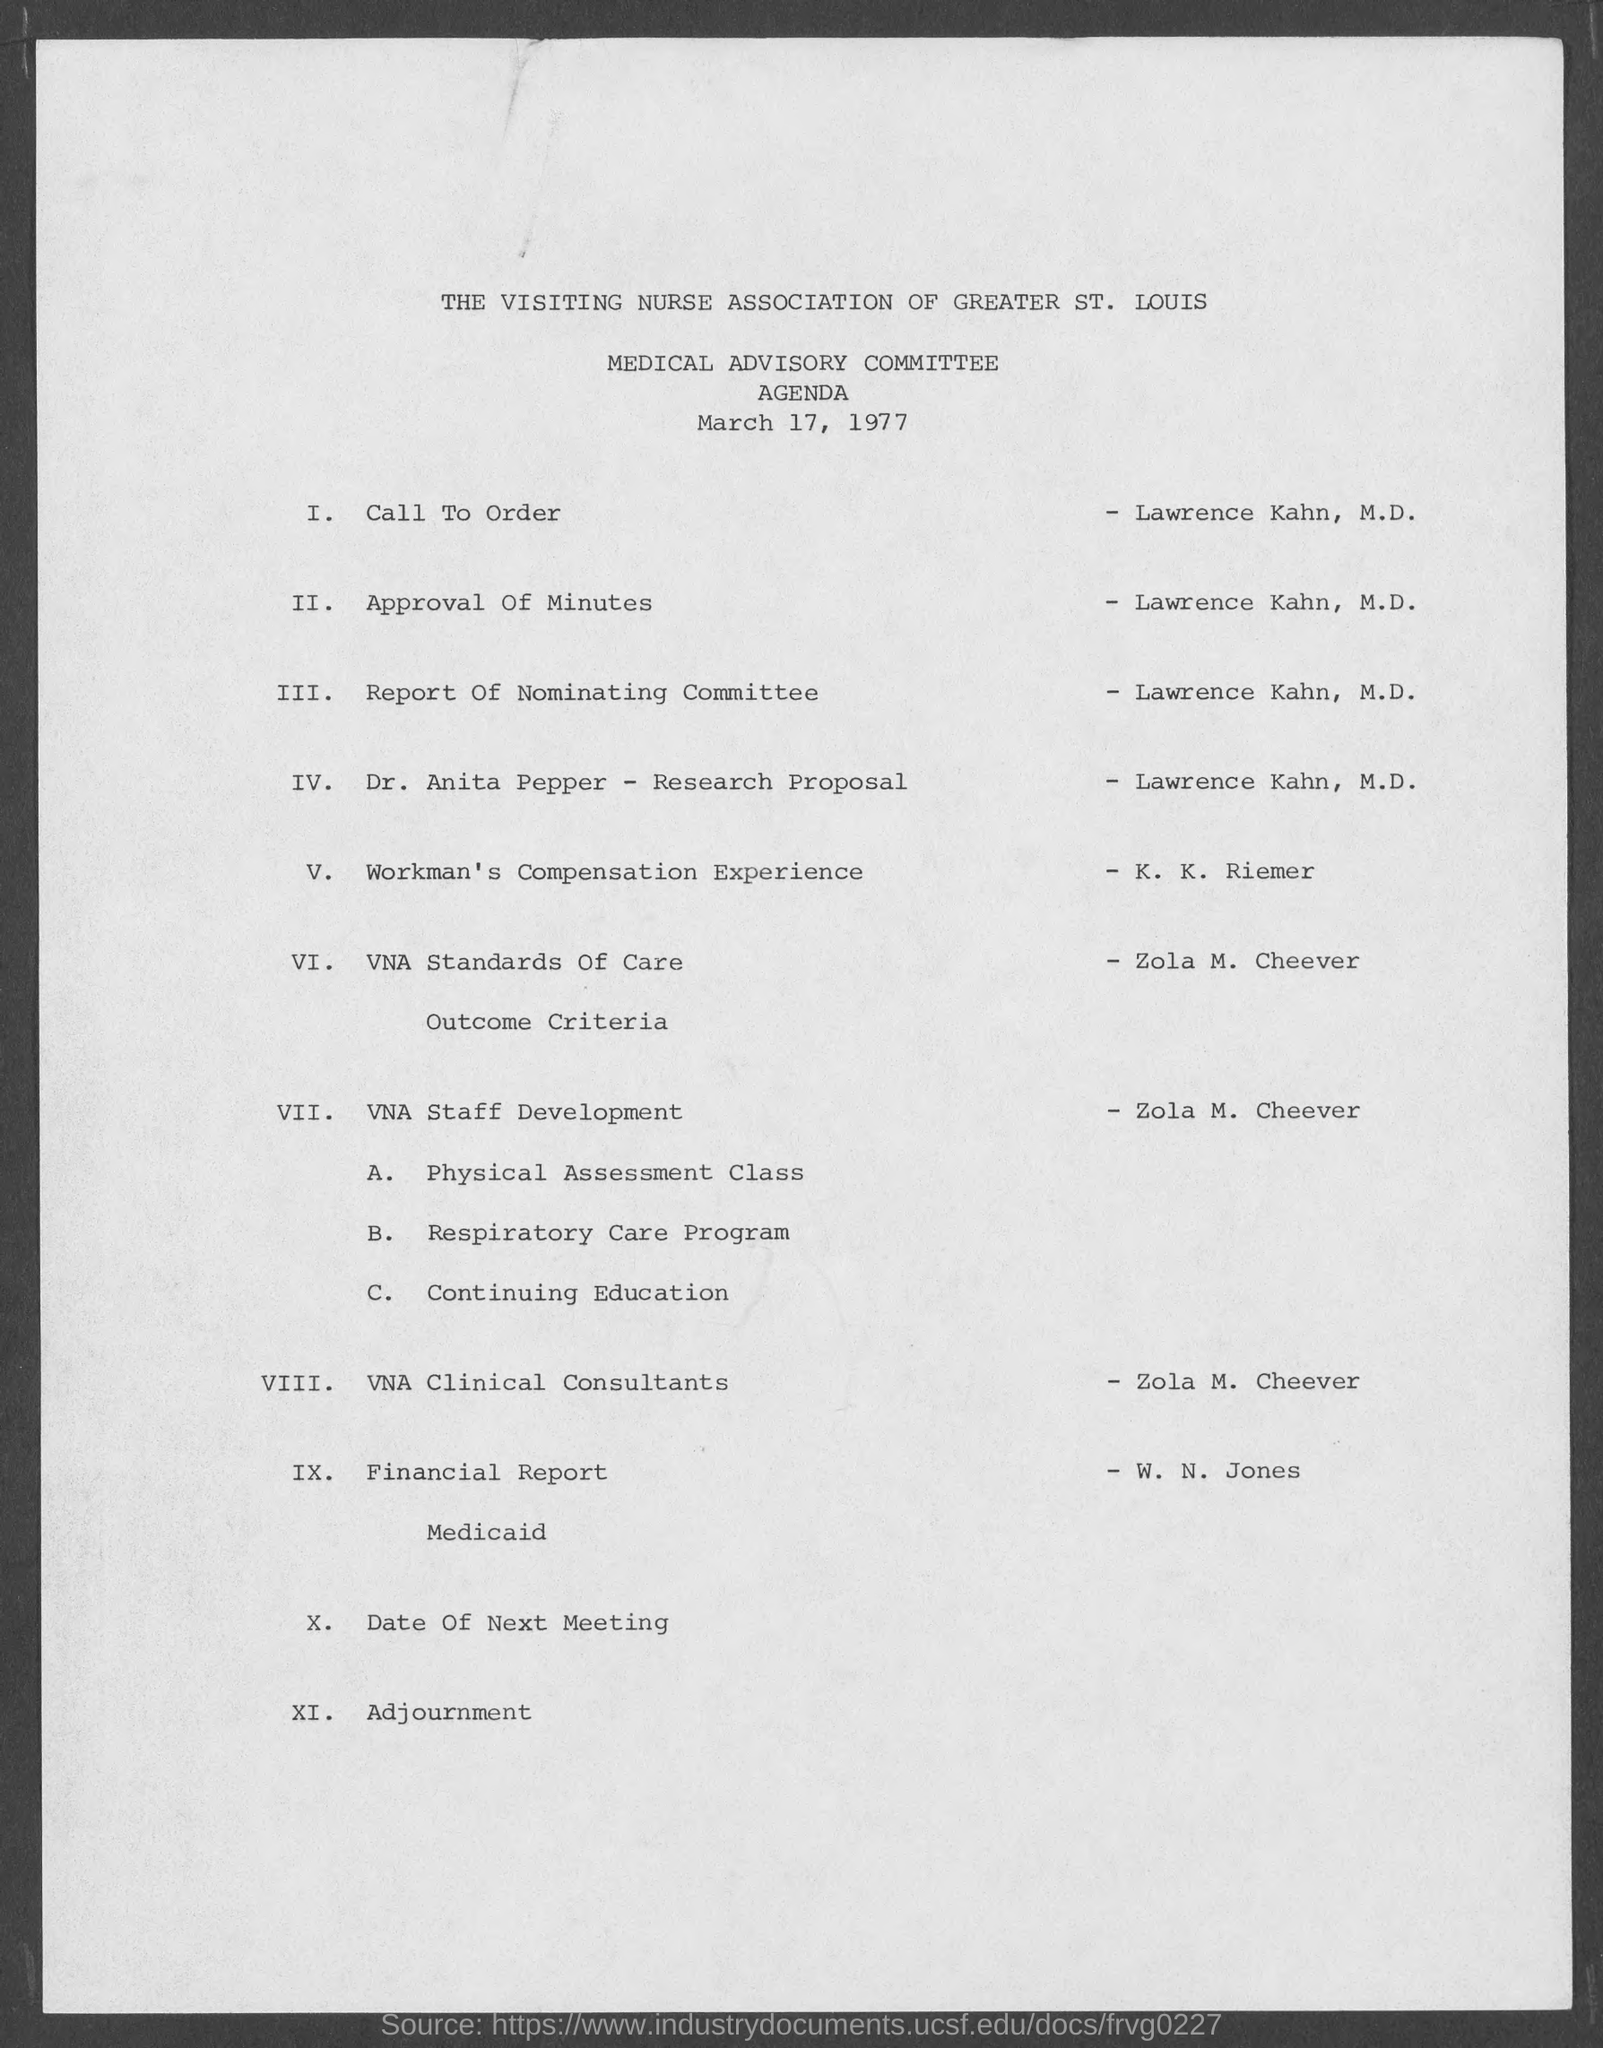Specify some key components in this picture. The speaker stated that "Lawrence Kahn is doing the Call To Order. The document is dated March 17, 1977. The individual responsible for preparing the financial report is W. N. Jones. The Medical Advisory Committee is mentioned. K. K. Riemer's topic is related to Workman's Compensation Experience. 